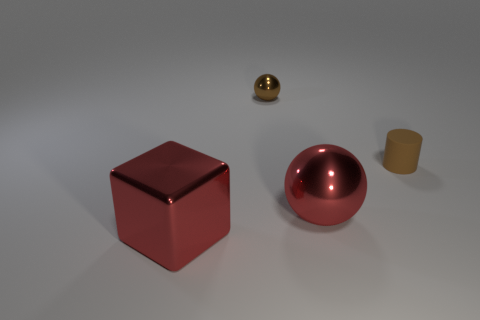Add 3 small balls. How many objects exist? 7 Subtract all cubes. How many objects are left? 3 Add 3 large shiny blocks. How many large shiny blocks exist? 4 Subtract 0 yellow balls. How many objects are left? 4 Subtract all small brown cylinders. Subtract all red balls. How many objects are left? 2 Add 3 small brown matte cylinders. How many small brown matte cylinders are left? 4 